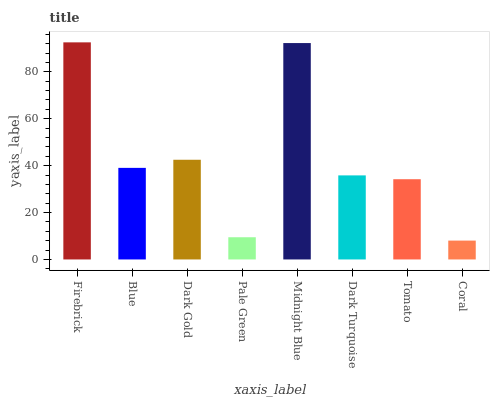Is Coral the minimum?
Answer yes or no. Yes. Is Firebrick the maximum?
Answer yes or no. Yes. Is Blue the minimum?
Answer yes or no. No. Is Blue the maximum?
Answer yes or no. No. Is Firebrick greater than Blue?
Answer yes or no. Yes. Is Blue less than Firebrick?
Answer yes or no. Yes. Is Blue greater than Firebrick?
Answer yes or no. No. Is Firebrick less than Blue?
Answer yes or no. No. Is Blue the high median?
Answer yes or no. Yes. Is Dark Turquoise the low median?
Answer yes or no. Yes. Is Coral the high median?
Answer yes or no. No. Is Midnight Blue the low median?
Answer yes or no. No. 